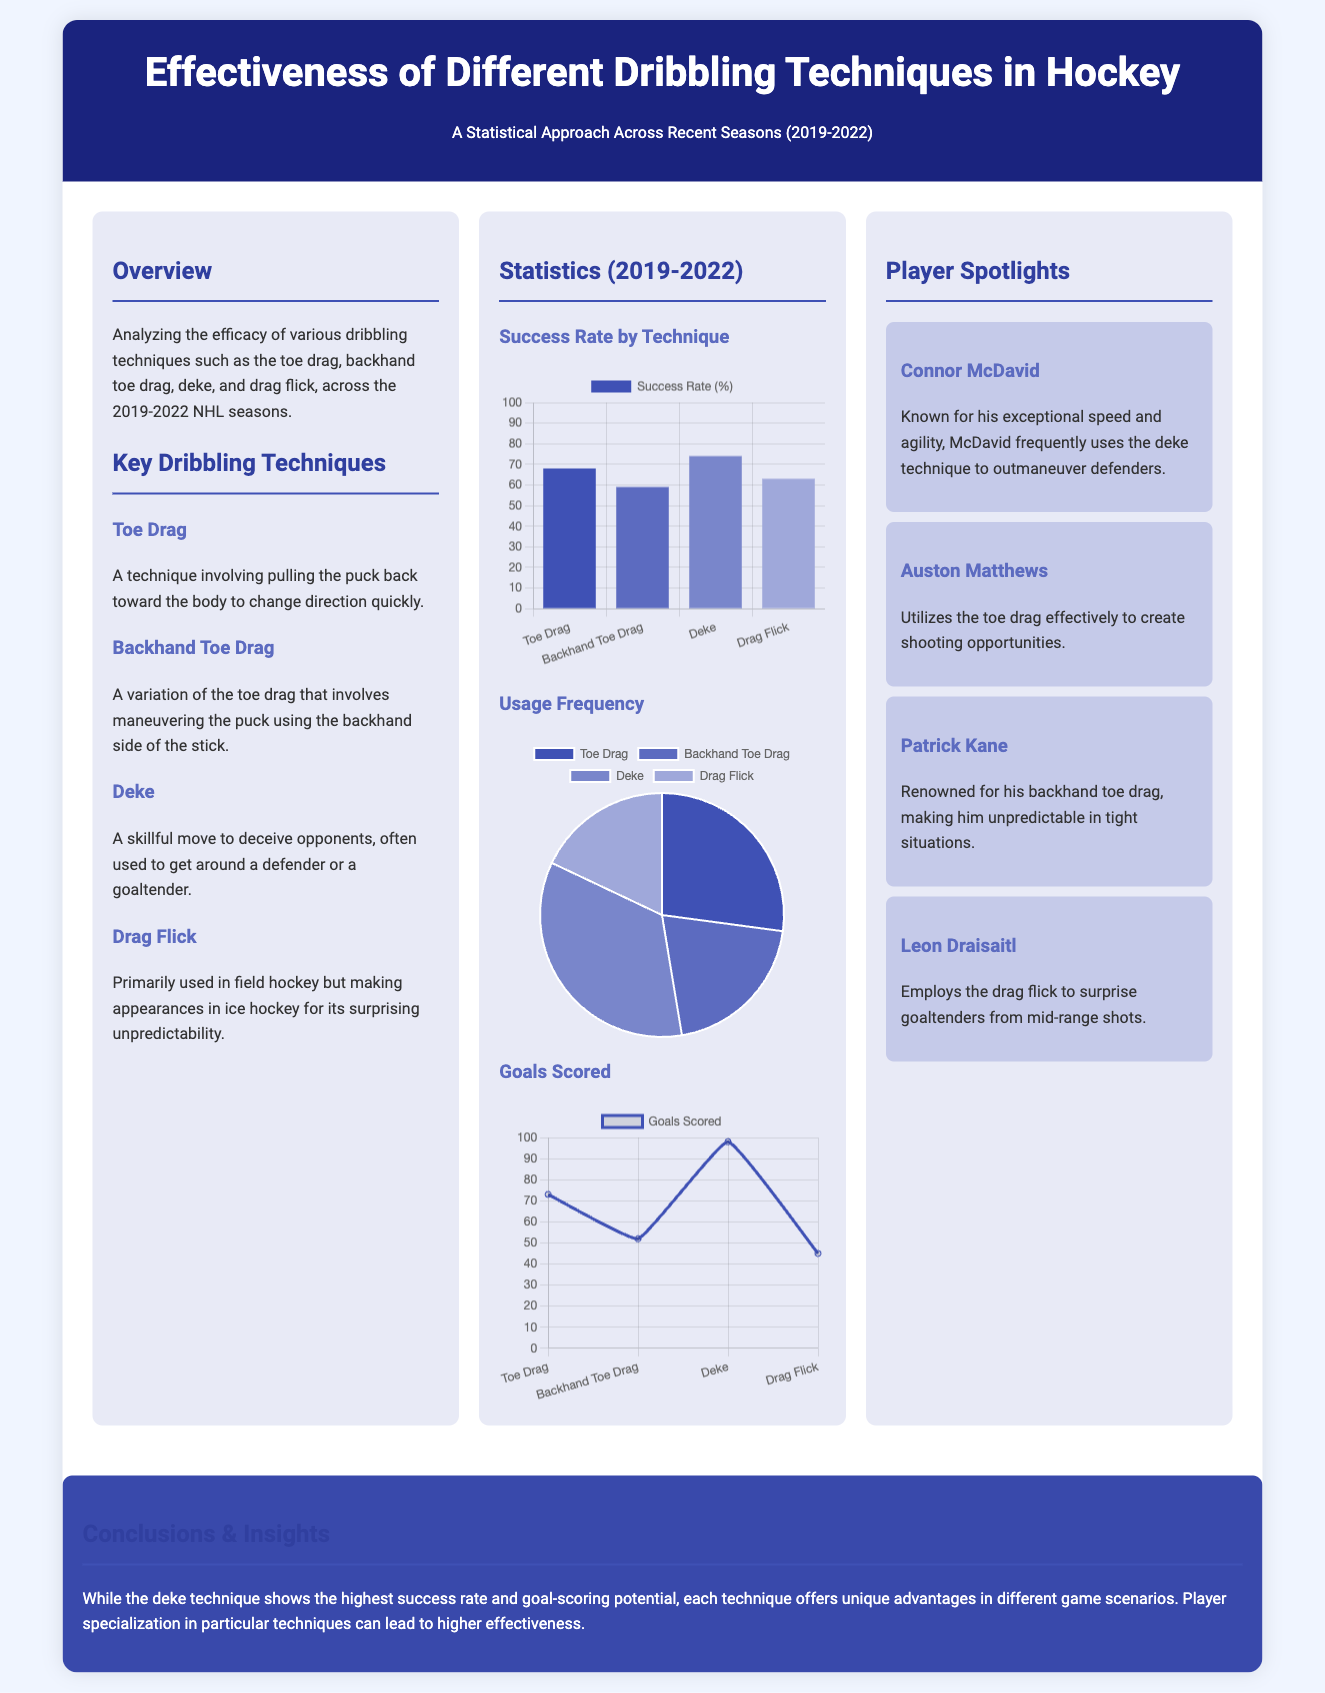What is the highest success rate technique? The highest success rate technique is identified in the success rate chart.
Answer: Deke What percentage is the success rate of the toe drag technique? The success rate of the toe drag technique is shown in the success rate chart.
Answer: 68% Which technique had the lowest number of goals scored? The goals scored for each technique are displayed on the line chart.
Answer: Drag Flick What is the usage frequency of the deke technique? The usage frequency of the deke technique can be found in the pie chart segment corresponding to it.
Answer: 530 Who is known for the backhand toe drag technique? The player spotlight section mentions who uses the backhand toe drag technique.
Answer: Patrick Kane How many goals were scored using the deke technique? The goals scored by technique are detailed in the goals scored chart.
Answer: 98 What is the frequency of the drag flick technique? The drag flick technique data is illustrated in the usage frequency pie chart.
Answer: 275 What conclusion is drawn about the effectiveness of dribbling techniques? The overall insight into the effectiveness of different techniques is summarized in the conclusion section.
Answer: Unique advantages What is the total number of goals scored across all techniques? This would require summation from the goals scored chart. 73 + 52 + 98 + 45 = 268.
Answer: 268 